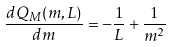<formula> <loc_0><loc_0><loc_500><loc_500>\frac { d Q _ { M } ( m , L ) } { d m } = - \frac { 1 } { L } + \frac { 1 } { m ^ { 2 } }</formula> 